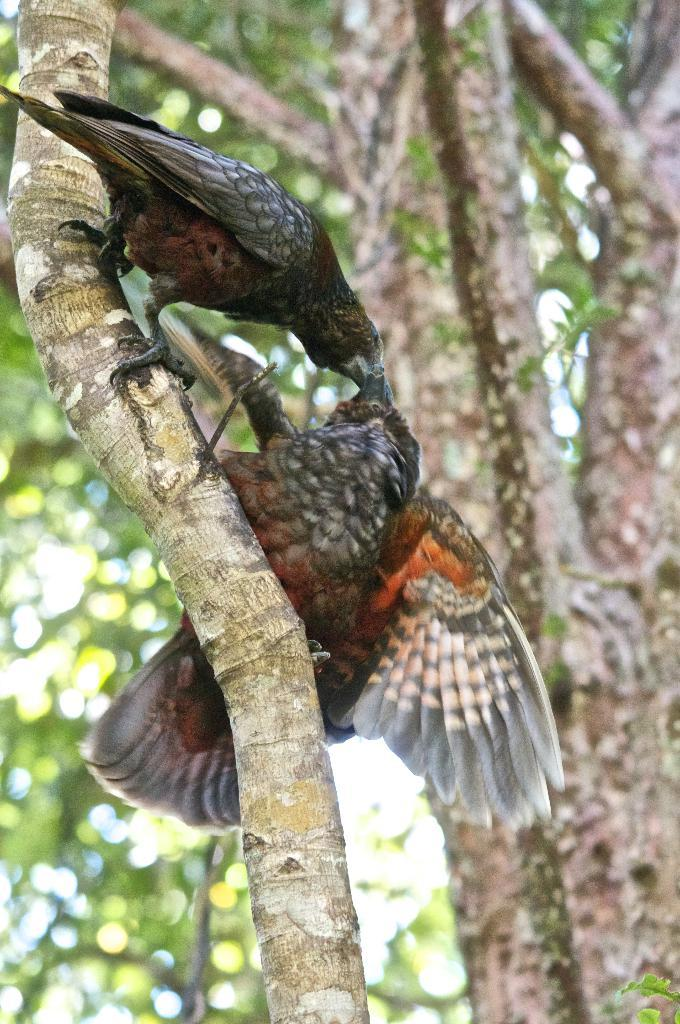How many birds are present in the image? There are two birds in the image. What are the birds doing in the image? The birds are standing on a branch. What can be seen in the background of the image? There is a tree in the background of the image. What type of property does the queen own in the image? There is no reference to a queen or any property in the image, as it features two birds standing on a branch. 